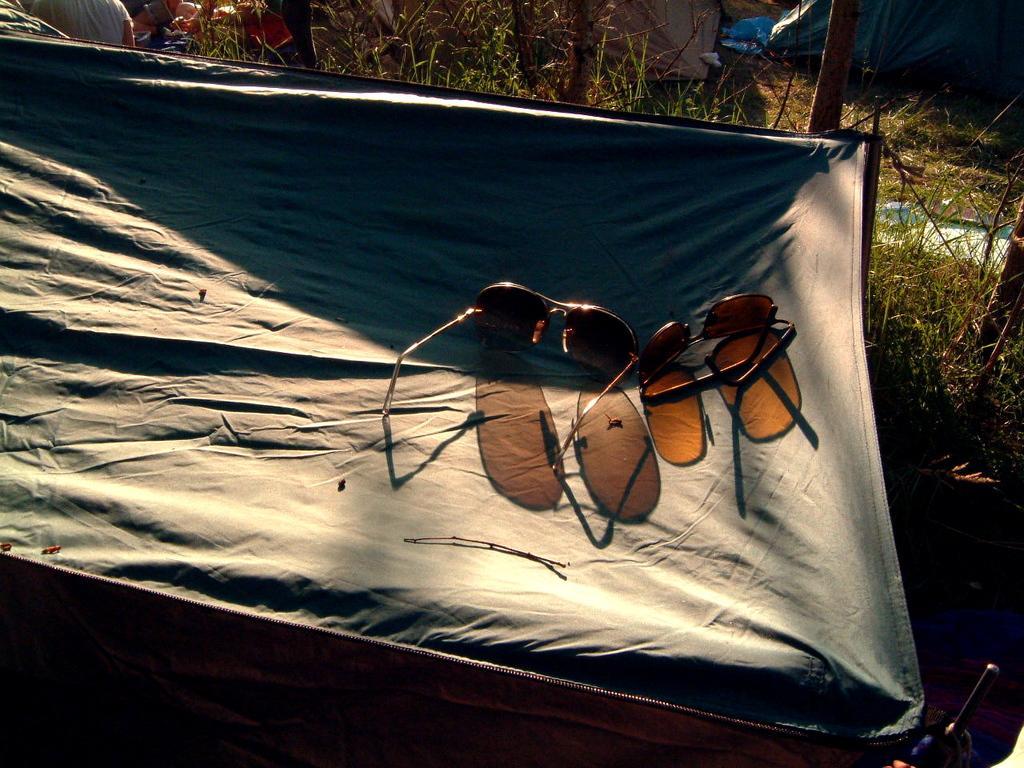Please provide a concise description of this image. Here we can see goggles. Background there is a grass. 